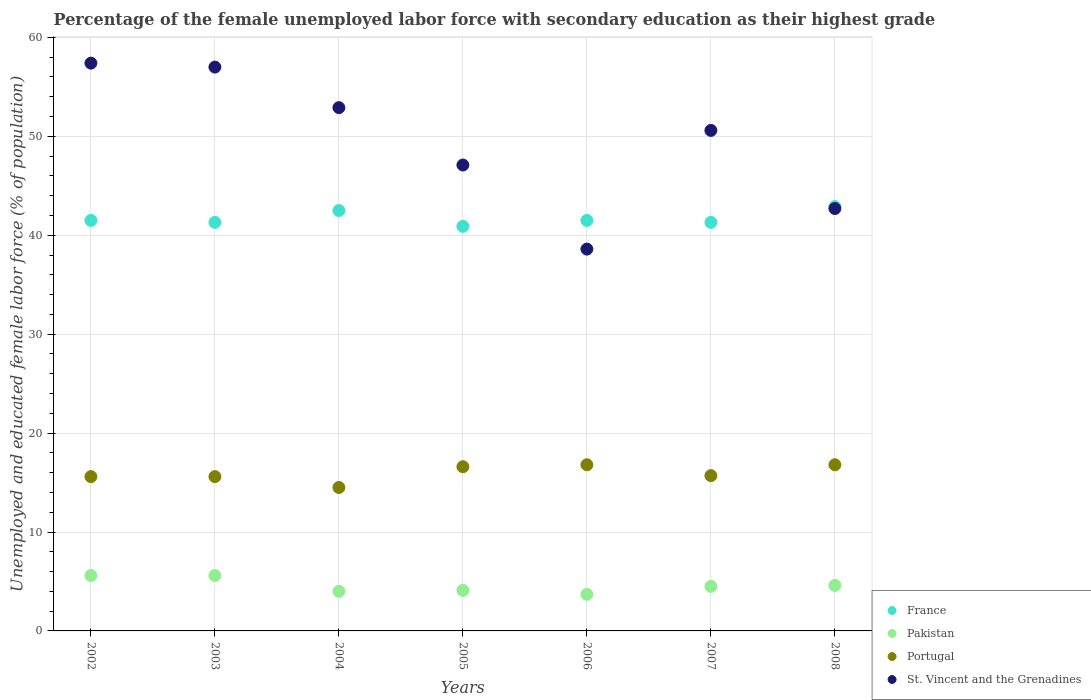How many different coloured dotlines are there?
Make the answer very short. 4. Is the number of dotlines equal to the number of legend labels?
Keep it short and to the point. Yes. What is the percentage of the unemployed female labor force with secondary education in Pakistan in 2002?
Keep it short and to the point. 5.6. Across all years, what is the maximum percentage of the unemployed female labor force with secondary education in Pakistan?
Offer a terse response. 5.6. Across all years, what is the minimum percentage of the unemployed female labor force with secondary education in St. Vincent and the Grenadines?
Your response must be concise. 38.6. What is the total percentage of the unemployed female labor force with secondary education in France in the graph?
Ensure brevity in your answer.  291.9. What is the difference between the percentage of the unemployed female labor force with secondary education in Portugal in 2002 and the percentage of the unemployed female labor force with secondary education in St. Vincent and the Grenadines in 2007?
Your answer should be very brief. -35. What is the average percentage of the unemployed female labor force with secondary education in St. Vincent and the Grenadines per year?
Give a very brief answer. 49.47. In the year 2008, what is the difference between the percentage of the unemployed female labor force with secondary education in Pakistan and percentage of the unemployed female labor force with secondary education in Portugal?
Keep it short and to the point. -12.2. What is the ratio of the percentage of the unemployed female labor force with secondary education in Pakistan in 2003 to that in 2004?
Ensure brevity in your answer.  1.4. What is the difference between the highest and the second highest percentage of the unemployed female labor force with secondary education in France?
Ensure brevity in your answer.  0.4. What is the difference between the highest and the lowest percentage of the unemployed female labor force with secondary education in St. Vincent and the Grenadines?
Keep it short and to the point. 18.8. Is it the case that in every year, the sum of the percentage of the unemployed female labor force with secondary education in Portugal and percentage of the unemployed female labor force with secondary education in Pakistan  is greater than the percentage of the unemployed female labor force with secondary education in St. Vincent and the Grenadines?
Give a very brief answer. No. Is the percentage of the unemployed female labor force with secondary education in Portugal strictly greater than the percentage of the unemployed female labor force with secondary education in Pakistan over the years?
Ensure brevity in your answer.  Yes. How many years are there in the graph?
Keep it short and to the point. 7. What is the difference between two consecutive major ticks on the Y-axis?
Make the answer very short. 10. Are the values on the major ticks of Y-axis written in scientific E-notation?
Your answer should be compact. No. Does the graph contain any zero values?
Make the answer very short. No. How are the legend labels stacked?
Offer a terse response. Vertical. What is the title of the graph?
Your response must be concise. Percentage of the female unemployed labor force with secondary education as their highest grade. Does "Costa Rica" appear as one of the legend labels in the graph?
Provide a succinct answer. No. What is the label or title of the X-axis?
Your response must be concise. Years. What is the label or title of the Y-axis?
Ensure brevity in your answer.  Unemployed and educated female labor force (% of population). What is the Unemployed and educated female labor force (% of population) in France in 2002?
Your response must be concise. 41.5. What is the Unemployed and educated female labor force (% of population) of Pakistan in 2002?
Keep it short and to the point. 5.6. What is the Unemployed and educated female labor force (% of population) of Portugal in 2002?
Keep it short and to the point. 15.6. What is the Unemployed and educated female labor force (% of population) in St. Vincent and the Grenadines in 2002?
Make the answer very short. 57.4. What is the Unemployed and educated female labor force (% of population) of France in 2003?
Give a very brief answer. 41.3. What is the Unemployed and educated female labor force (% of population) in Pakistan in 2003?
Offer a terse response. 5.6. What is the Unemployed and educated female labor force (% of population) in Portugal in 2003?
Ensure brevity in your answer.  15.6. What is the Unemployed and educated female labor force (% of population) of France in 2004?
Give a very brief answer. 42.5. What is the Unemployed and educated female labor force (% of population) of Portugal in 2004?
Provide a succinct answer. 14.5. What is the Unemployed and educated female labor force (% of population) in St. Vincent and the Grenadines in 2004?
Your response must be concise. 52.9. What is the Unemployed and educated female labor force (% of population) of France in 2005?
Your answer should be compact. 40.9. What is the Unemployed and educated female labor force (% of population) in Pakistan in 2005?
Ensure brevity in your answer.  4.1. What is the Unemployed and educated female labor force (% of population) of Portugal in 2005?
Provide a succinct answer. 16.6. What is the Unemployed and educated female labor force (% of population) in St. Vincent and the Grenadines in 2005?
Your response must be concise. 47.1. What is the Unemployed and educated female labor force (% of population) in France in 2006?
Offer a very short reply. 41.5. What is the Unemployed and educated female labor force (% of population) in Pakistan in 2006?
Make the answer very short. 3.7. What is the Unemployed and educated female labor force (% of population) of Portugal in 2006?
Your answer should be very brief. 16.8. What is the Unemployed and educated female labor force (% of population) in St. Vincent and the Grenadines in 2006?
Offer a very short reply. 38.6. What is the Unemployed and educated female labor force (% of population) of France in 2007?
Your answer should be compact. 41.3. What is the Unemployed and educated female labor force (% of population) of Portugal in 2007?
Provide a short and direct response. 15.7. What is the Unemployed and educated female labor force (% of population) of St. Vincent and the Grenadines in 2007?
Provide a short and direct response. 50.6. What is the Unemployed and educated female labor force (% of population) of France in 2008?
Your answer should be very brief. 42.9. What is the Unemployed and educated female labor force (% of population) of Pakistan in 2008?
Ensure brevity in your answer.  4.6. What is the Unemployed and educated female labor force (% of population) in Portugal in 2008?
Offer a very short reply. 16.8. What is the Unemployed and educated female labor force (% of population) of St. Vincent and the Grenadines in 2008?
Ensure brevity in your answer.  42.7. Across all years, what is the maximum Unemployed and educated female labor force (% of population) in France?
Ensure brevity in your answer.  42.9. Across all years, what is the maximum Unemployed and educated female labor force (% of population) in Pakistan?
Ensure brevity in your answer.  5.6. Across all years, what is the maximum Unemployed and educated female labor force (% of population) of Portugal?
Your answer should be compact. 16.8. Across all years, what is the maximum Unemployed and educated female labor force (% of population) in St. Vincent and the Grenadines?
Ensure brevity in your answer.  57.4. Across all years, what is the minimum Unemployed and educated female labor force (% of population) in France?
Keep it short and to the point. 40.9. Across all years, what is the minimum Unemployed and educated female labor force (% of population) of Pakistan?
Keep it short and to the point. 3.7. Across all years, what is the minimum Unemployed and educated female labor force (% of population) in St. Vincent and the Grenadines?
Your answer should be very brief. 38.6. What is the total Unemployed and educated female labor force (% of population) of France in the graph?
Provide a short and direct response. 291.9. What is the total Unemployed and educated female labor force (% of population) in Pakistan in the graph?
Your response must be concise. 32.1. What is the total Unemployed and educated female labor force (% of population) in Portugal in the graph?
Provide a short and direct response. 111.6. What is the total Unemployed and educated female labor force (% of population) of St. Vincent and the Grenadines in the graph?
Your answer should be very brief. 346.3. What is the difference between the Unemployed and educated female labor force (% of population) of France in 2002 and that in 2003?
Provide a short and direct response. 0.2. What is the difference between the Unemployed and educated female labor force (% of population) of Pakistan in 2002 and that in 2004?
Offer a very short reply. 1.6. What is the difference between the Unemployed and educated female labor force (% of population) in Portugal in 2002 and that in 2004?
Provide a succinct answer. 1.1. What is the difference between the Unemployed and educated female labor force (% of population) of St. Vincent and the Grenadines in 2002 and that in 2004?
Provide a succinct answer. 4.5. What is the difference between the Unemployed and educated female labor force (% of population) in France in 2002 and that in 2005?
Ensure brevity in your answer.  0.6. What is the difference between the Unemployed and educated female labor force (% of population) of Pakistan in 2002 and that in 2005?
Provide a succinct answer. 1.5. What is the difference between the Unemployed and educated female labor force (% of population) of Portugal in 2002 and that in 2005?
Your answer should be compact. -1. What is the difference between the Unemployed and educated female labor force (% of population) of Pakistan in 2002 and that in 2006?
Your answer should be compact. 1.9. What is the difference between the Unemployed and educated female labor force (% of population) in Portugal in 2002 and that in 2006?
Ensure brevity in your answer.  -1.2. What is the difference between the Unemployed and educated female labor force (% of population) of St. Vincent and the Grenadines in 2002 and that in 2006?
Ensure brevity in your answer.  18.8. What is the difference between the Unemployed and educated female labor force (% of population) in Portugal in 2002 and that in 2007?
Ensure brevity in your answer.  -0.1. What is the difference between the Unemployed and educated female labor force (% of population) of St. Vincent and the Grenadines in 2002 and that in 2007?
Offer a very short reply. 6.8. What is the difference between the Unemployed and educated female labor force (% of population) of France in 2002 and that in 2008?
Your answer should be very brief. -1.4. What is the difference between the Unemployed and educated female labor force (% of population) in Pakistan in 2002 and that in 2008?
Make the answer very short. 1. What is the difference between the Unemployed and educated female labor force (% of population) of France in 2003 and that in 2004?
Your answer should be very brief. -1.2. What is the difference between the Unemployed and educated female labor force (% of population) in St. Vincent and the Grenadines in 2003 and that in 2004?
Your response must be concise. 4.1. What is the difference between the Unemployed and educated female labor force (% of population) of Portugal in 2003 and that in 2005?
Keep it short and to the point. -1. What is the difference between the Unemployed and educated female labor force (% of population) of France in 2003 and that in 2006?
Make the answer very short. -0.2. What is the difference between the Unemployed and educated female labor force (% of population) of Portugal in 2003 and that in 2006?
Offer a terse response. -1.2. What is the difference between the Unemployed and educated female labor force (% of population) of St. Vincent and the Grenadines in 2003 and that in 2006?
Your answer should be compact. 18.4. What is the difference between the Unemployed and educated female labor force (% of population) in Pakistan in 2003 and that in 2007?
Provide a short and direct response. 1.1. What is the difference between the Unemployed and educated female labor force (% of population) of Pakistan in 2003 and that in 2008?
Your answer should be very brief. 1. What is the difference between the Unemployed and educated female labor force (% of population) of France in 2004 and that in 2006?
Offer a terse response. 1. What is the difference between the Unemployed and educated female labor force (% of population) of Portugal in 2004 and that in 2006?
Keep it short and to the point. -2.3. What is the difference between the Unemployed and educated female labor force (% of population) of St. Vincent and the Grenadines in 2004 and that in 2006?
Ensure brevity in your answer.  14.3. What is the difference between the Unemployed and educated female labor force (% of population) in Pakistan in 2004 and that in 2007?
Offer a very short reply. -0.5. What is the difference between the Unemployed and educated female labor force (% of population) of St. Vincent and the Grenadines in 2004 and that in 2007?
Give a very brief answer. 2.3. What is the difference between the Unemployed and educated female labor force (% of population) of Pakistan in 2004 and that in 2008?
Offer a terse response. -0.6. What is the difference between the Unemployed and educated female labor force (% of population) of Portugal in 2004 and that in 2008?
Ensure brevity in your answer.  -2.3. What is the difference between the Unemployed and educated female labor force (% of population) of St. Vincent and the Grenadines in 2004 and that in 2008?
Ensure brevity in your answer.  10.2. What is the difference between the Unemployed and educated female labor force (% of population) in Portugal in 2005 and that in 2006?
Make the answer very short. -0.2. What is the difference between the Unemployed and educated female labor force (% of population) of Pakistan in 2005 and that in 2007?
Offer a very short reply. -0.4. What is the difference between the Unemployed and educated female labor force (% of population) of France in 2005 and that in 2008?
Keep it short and to the point. -2. What is the difference between the Unemployed and educated female labor force (% of population) in Portugal in 2005 and that in 2008?
Make the answer very short. -0.2. What is the difference between the Unemployed and educated female labor force (% of population) of St. Vincent and the Grenadines in 2005 and that in 2008?
Give a very brief answer. 4.4. What is the difference between the Unemployed and educated female labor force (% of population) in Pakistan in 2006 and that in 2008?
Your answer should be very brief. -0.9. What is the difference between the Unemployed and educated female labor force (% of population) in Portugal in 2006 and that in 2008?
Your answer should be compact. 0. What is the difference between the Unemployed and educated female labor force (% of population) in St. Vincent and the Grenadines in 2006 and that in 2008?
Provide a succinct answer. -4.1. What is the difference between the Unemployed and educated female labor force (% of population) in France in 2007 and that in 2008?
Give a very brief answer. -1.6. What is the difference between the Unemployed and educated female labor force (% of population) in Portugal in 2007 and that in 2008?
Offer a terse response. -1.1. What is the difference between the Unemployed and educated female labor force (% of population) of St. Vincent and the Grenadines in 2007 and that in 2008?
Provide a short and direct response. 7.9. What is the difference between the Unemployed and educated female labor force (% of population) of France in 2002 and the Unemployed and educated female labor force (% of population) of Pakistan in 2003?
Your answer should be very brief. 35.9. What is the difference between the Unemployed and educated female labor force (% of population) in France in 2002 and the Unemployed and educated female labor force (% of population) in Portugal in 2003?
Your answer should be compact. 25.9. What is the difference between the Unemployed and educated female labor force (% of population) in France in 2002 and the Unemployed and educated female labor force (% of population) in St. Vincent and the Grenadines in 2003?
Make the answer very short. -15.5. What is the difference between the Unemployed and educated female labor force (% of population) of Pakistan in 2002 and the Unemployed and educated female labor force (% of population) of St. Vincent and the Grenadines in 2003?
Offer a terse response. -51.4. What is the difference between the Unemployed and educated female labor force (% of population) of Portugal in 2002 and the Unemployed and educated female labor force (% of population) of St. Vincent and the Grenadines in 2003?
Your answer should be very brief. -41.4. What is the difference between the Unemployed and educated female labor force (% of population) in France in 2002 and the Unemployed and educated female labor force (% of population) in Pakistan in 2004?
Your answer should be very brief. 37.5. What is the difference between the Unemployed and educated female labor force (% of population) of France in 2002 and the Unemployed and educated female labor force (% of population) of Portugal in 2004?
Your answer should be very brief. 27. What is the difference between the Unemployed and educated female labor force (% of population) in France in 2002 and the Unemployed and educated female labor force (% of population) in St. Vincent and the Grenadines in 2004?
Offer a terse response. -11.4. What is the difference between the Unemployed and educated female labor force (% of population) of Pakistan in 2002 and the Unemployed and educated female labor force (% of population) of Portugal in 2004?
Keep it short and to the point. -8.9. What is the difference between the Unemployed and educated female labor force (% of population) of Pakistan in 2002 and the Unemployed and educated female labor force (% of population) of St. Vincent and the Grenadines in 2004?
Keep it short and to the point. -47.3. What is the difference between the Unemployed and educated female labor force (% of population) of Portugal in 2002 and the Unemployed and educated female labor force (% of population) of St. Vincent and the Grenadines in 2004?
Provide a short and direct response. -37.3. What is the difference between the Unemployed and educated female labor force (% of population) of France in 2002 and the Unemployed and educated female labor force (% of population) of Pakistan in 2005?
Keep it short and to the point. 37.4. What is the difference between the Unemployed and educated female labor force (% of population) in France in 2002 and the Unemployed and educated female labor force (% of population) in Portugal in 2005?
Offer a terse response. 24.9. What is the difference between the Unemployed and educated female labor force (% of population) of Pakistan in 2002 and the Unemployed and educated female labor force (% of population) of St. Vincent and the Grenadines in 2005?
Offer a terse response. -41.5. What is the difference between the Unemployed and educated female labor force (% of population) of Portugal in 2002 and the Unemployed and educated female labor force (% of population) of St. Vincent and the Grenadines in 2005?
Offer a very short reply. -31.5. What is the difference between the Unemployed and educated female labor force (% of population) of France in 2002 and the Unemployed and educated female labor force (% of population) of Pakistan in 2006?
Offer a terse response. 37.8. What is the difference between the Unemployed and educated female labor force (% of population) in France in 2002 and the Unemployed and educated female labor force (% of population) in Portugal in 2006?
Ensure brevity in your answer.  24.7. What is the difference between the Unemployed and educated female labor force (% of population) of France in 2002 and the Unemployed and educated female labor force (% of population) of St. Vincent and the Grenadines in 2006?
Provide a short and direct response. 2.9. What is the difference between the Unemployed and educated female labor force (% of population) of Pakistan in 2002 and the Unemployed and educated female labor force (% of population) of Portugal in 2006?
Provide a succinct answer. -11.2. What is the difference between the Unemployed and educated female labor force (% of population) of Pakistan in 2002 and the Unemployed and educated female labor force (% of population) of St. Vincent and the Grenadines in 2006?
Offer a very short reply. -33. What is the difference between the Unemployed and educated female labor force (% of population) in Portugal in 2002 and the Unemployed and educated female labor force (% of population) in St. Vincent and the Grenadines in 2006?
Your answer should be very brief. -23. What is the difference between the Unemployed and educated female labor force (% of population) in France in 2002 and the Unemployed and educated female labor force (% of population) in Pakistan in 2007?
Provide a succinct answer. 37. What is the difference between the Unemployed and educated female labor force (% of population) of France in 2002 and the Unemployed and educated female labor force (% of population) of Portugal in 2007?
Offer a very short reply. 25.8. What is the difference between the Unemployed and educated female labor force (% of population) of France in 2002 and the Unemployed and educated female labor force (% of population) of St. Vincent and the Grenadines in 2007?
Provide a succinct answer. -9.1. What is the difference between the Unemployed and educated female labor force (% of population) of Pakistan in 2002 and the Unemployed and educated female labor force (% of population) of St. Vincent and the Grenadines in 2007?
Provide a succinct answer. -45. What is the difference between the Unemployed and educated female labor force (% of population) in Portugal in 2002 and the Unemployed and educated female labor force (% of population) in St. Vincent and the Grenadines in 2007?
Give a very brief answer. -35. What is the difference between the Unemployed and educated female labor force (% of population) of France in 2002 and the Unemployed and educated female labor force (% of population) of Pakistan in 2008?
Ensure brevity in your answer.  36.9. What is the difference between the Unemployed and educated female labor force (% of population) in France in 2002 and the Unemployed and educated female labor force (% of population) in Portugal in 2008?
Ensure brevity in your answer.  24.7. What is the difference between the Unemployed and educated female labor force (% of population) of France in 2002 and the Unemployed and educated female labor force (% of population) of St. Vincent and the Grenadines in 2008?
Give a very brief answer. -1.2. What is the difference between the Unemployed and educated female labor force (% of population) in Pakistan in 2002 and the Unemployed and educated female labor force (% of population) in Portugal in 2008?
Your response must be concise. -11.2. What is the difference between the Unemployed and educated female labor force (% of population) of Pakistan in 2002 and the Unemployed and educated female labor force (% of population) of St. Vincent and the Grenadines in 2008?
Provide a short and direct response. -37.1. What is the difference between the Unemployed and educated female labor force (% of population) in Portugal in 2002 and the Unemployed and educated female labor force (% of population) in St. Vincent and the Grenadines in 2008?
Keep it short and to the point. -27.1. What is the difference between the Unemployed and educated female labor force (% of population) of France in 2003 and the Unemployed and educated female labor force (% of population) of Pakistan in 2004?
Your answer should be very brief. 37.3. What is the difference between the Unemployed and educated female labor force (% of population) of France in 2003 and the Unemployed and educated female labor force (% of population) of Portugal in 2004?
Your answer should be compact. 26.8. What is the difference between the Unemployed and educated female labor force (% of population) of France in 2003 and the Unemployed and educated female labor force (% of population) of St. Vincent and the Grenadines in 2004?
Give a very brief answer. -11.6. What is the difference between the Unemployed and educated female labor force (% of population) in Pakistan in 2003 and the Unemployed and educated female labor force (% of population) in St. Vincent and the Grenadines in 2004?
Make the answer very short. -47.3. What is the difference between the Unemployed and educated female labor force (% of population) in Portugal in 2003 and the Unemployed and educated female labor force (% of population) in St. Vincent and the Grenadines in 2004?
Provide a succinct answer. -37.3. What is the difference between the Unemployed and educated female labor force (% of population) of France in 2003 and the Unemployed and educated female labor force (% of population) of Pakistan in 2005?
Provide a succinct answer. 37.2. What is the difference between the Unemployed and educated female labor force (% of population) of France in 2003 and the Unemployed and educated female labor force (% of population) of Portugal in 2005?
Provide a short and direct response. 24.7. What is the difference between the Unemployed and educated female labor force (% of population) in Pakistan in 2003 and the Unemployed and educated female labor force (% of population) in St. Vincent and the Grenadines in 2005?
Your response must be concise. -41.5. What is the difference between the Unemployed and educated female labor force (% of population) of Portugal in 2003 and the Unemployed and educated female labor force (% of population) of St. Vincent and the Grenadines in 2005?
Ensure brevity in your answer.  -31.5. What is the difference between the Unemployed and educated female labor force (% of population) of France in 2003 and the Unemployed and educated female labor force (% of population) of Pakistan in 2006?
Ensure brevity in your answer.  37.6. What is the difference between the Unemployed and educated female labor force (% of population) in France in 2003 and the Unemployed and educated female labor force (% of population) in Portugal in 2006?
Offer a terse response. 24.5. What is the difference between the Unemployed and educated female labor force (% of population) of Pakistan in 2003 and the Unemployed and educated female labor force (% of population) of Portugal in 2006?
Provide a short and direct response. -11.2. What is the difference between the Unemployed and educated female labor force (% of population) in Pakistan in 2003 and the Unemployed and educated female labor force (% of population) in St. Vincent and the Grenadines in 2006?
Give a very brief answer. -33. What is the difference between the Unemployed and educated female labor force (% of population) of Portugal in 2003 and the Unemployed and educated female labor force (% of population) of St. Vincent and the Grenadines in 2006?
Offer a very short reply. -23. What is the difference between the Unemployed and educated female labor force (% of population) in France in 2003 and the Unemployed and educated female labor force (% of population) in Pakistan in 2007?
Your answer should be very brief. 36.8. What is the difference between the Unemployed and educated female labor force (% of population) of France in 2003 and the Unemployed and educated female labor force (% of population) of Portugal in 2007?
Provide a short and direct response. 25.6. What is the difference between the Unemployed and educated female labor force (% of population) in Pakistan in 2003 and the Unemployed and educated female labor force (% of population) in Portugal in 2007?
Your answer should be compact. -10.1. What is the difference between the Unemployed and educated female labor force (% of population) of Pakistan in 2003 and the Unemployed and educated female labor force (% of population) of St. Vincent and the Grenadines in 2007?
Give a very brief answer. -45. What is the difference between the Unemployed and educated female labor force (% of population) in Portugal in 2003 and the Unemployed and educated female labor force (% of population) in St. Vincent and the Grenadines in 2007?
Your response must be concise. -35. What is the difference between the Unemployed and educated female labor force (% of population) in France in 2003 and the Unemployed and educated female labor force (% of population) in Pakistan in 2008?
Offer a very short reply. 36.7. What is the difference between the Unemployed and educated female labor force (% of population) of France in 2003 and the Unemployed and educated female labor force (% of population) of St. Vincent and the Grenadines in 2008?
Your answer should be very brief. -1.4. What is the difference between the Unemployed and educated female labor force (% of population) of Pakistan in 2003 and the Unemployed and educated female labor force (% of population) of Portugal in 2008?
Provide a succinct answer. -11.2. What is the difference between the Unemployed and educated female labor force (% of population) of Pakistan in 2003 and the Unemployed and educated female labor force (% of population) of St. Vincent and the Grenadines in 2008?
Your answer should be compact. -37.1. What is the difference between the Unemployed and educated female labor force (% of population) in Portugal in 2003 and the Unemployed and educated female labor force (% of population) in St. Vincent and the Grenadines in 2008?
Keep it short and to the point. -27.1. What is the difference between the Unemployed and educated female labor force (% of population) in France in 2004 and the Unemployed and educated female labor force (% of population) in Pakistan in 2005?
Provide a short and direct response. 38.4. What is the difference between the Unemployed and educated female labor force (% of population) of France in 2004 and the Unemployed and educated female labor force (% of population) of Portugal in 2005?
Your response must be concise. 25.9. What is the difference between the Unemployed and educated female labor force (% of population) of France in 2004 and the Unemployed and educated female labor force (% of population) of St. Vincent and the Grenadines in 2005?
Ensure brevity in your answer.  -4.6. What is the difference between the Unemployed and educated female labor force (% of population) of Pakistan in 2004 and the Unemployed and educated female labor force (% of population) of St. Vincent and the Grenadines in 2005?
Your answer should be compact. -43.1. What is the difference between the Unemployed and educated female labor force (% of population) of Portugal in 2004 and the Unemployed and educated female labor force (% of population) of St. Vincent and the Grenadines in 2005?
Your answer should be compact. -32.6. What is the difference between the Unemployed and educated female labor force (% of population) in France in 2004 and the Unemployed and educated female labor force (% of population) in Pakistan in 2006?
Offer a very short reply. 38.8. What is the difference between the Unemployed and educated female labor force (% of population) of France in 2004 and the Unemployed and educated female labor force (% of population) of Portugal in 2006?
Offer a very short reply. 25.7. What is the difference between the Unemployed and educated female labor force (% of population) in Pakistan in 2004 and the Unemployed and educated female labor force (% of population) in Portugal in 2006?
Your answer should be compact. -12.8. What is the difference between the Unemployed and educated female labor force (% of population) of Pakistan in 2004 and the Unemployed and educated female labor force (% of population) of St. Vincent and the Grenadines in 2006?
Make the answer very short. -34.6. What is the difference between the Unemployed and educated female labor force (% of population) of Portugal in 2004 and the Unemployed and educated female labor force (% of population) of St. Vincent and the Grenadines in 2006?
Your answer should be compact. -24.1. What is the difference between the Unemployed and educated female labor force (% of population) in France in 2004 and the Unemployed and educated female labor force (% of population) in Pakistan in 2007?
Give a very brief answer. 38. What is the difference between the Unemployed and educated female labor force (% of population) of France in 2004 and the Unemployed and educated female labor force (% of population) of Portugal in 2007?
Ensure brevity in your answer.  26.8. What is the difference between the Unemployed and educated female labor force (% of population) of Pakistan in 2004 and the Unemployed and educated female labor force (% of population) of Portugal in 2007?
Your response must be concise. -11.7. What is the difference between the Unemployed and educated female labor force (% of population) of Pakistan in 2004 and the Unemployed and educated female labor force (% of population) of St. Vincent and the Grenadines in 2007?
Ensure brevity in your answer.  -46.6. What is the difference between the Unemployed and educated female labor force (% of population) in Portugal in 2004 and the Unemployed and educated female labor force (% of population) in St. Vincent and the Grenadines in 2007?
Your answer should be compact. -36.1. What is the difference between the Unemployed and educated female labor force (% of population) of France in 2004 and the Unemployed and educated female labor force (% of population) of Pakistan in 2008?
Your answer should be compact. 37.9. What is the difference between the Unemployed and educated female labor force (% of population) in France in 2004 and the Unemployed and educated female labor force (% of population) in Portugal in 2008?
Your answer should be very brief. 25.7. What is the difference between the Unemployed and educated female labor force (% of population) in France in 2004 and the Unemployed and educated female labor force (% of population) in St. Vincent and the Grenadines in 2008?
Provide a succinct answer. -0.2. What is the difference between the Unemployed and educated female labor force (% of population) in Pakistan in 2004 and the Unemployed and educated female labor force (% of population) in St. Vincent and the Grenadines in 2008?
Give a very brief answer. -38.7. What is the difference between the Unemployed and educated female labor force (% of population) of Portugal in 2004 and the Unemployed and educated female labor force (% of population) of St. Vincent and the Grenadines in 2008?
Ensure brevity in your answer.  -28.2. What is the difference between the Unemployed and educated female labor force (% of population) in France in 2005 and the Unemployed and educated female labor force (% of population) in Pakistan in 2006?
Offer a very short reply. 37.2. What is the difference between the Unemployed and educated female labor force (% of population) in France in 2005 and the Unemployed and educated female labor force (% of population) in Portugal in 2006?
Offer a terse response. 24.1. What is the difference between the Unemployed and educated female labor force (% of population) in France in 2005 and the Unemployed and educated female labor force (% of population) in St. Vincent and the Grenadines in 2006?
Give a very brief answer. 2.3. What is the difference between the Unemployed and educated female labor force (% of population) of Pakistan in 2005 and the Unemployed and educated female labor force (% of population) of St. Vincent and the Grenadines in 2006?
Keep it short and to the point. -34.5. What is the difference between the Unemployed and educated female labor force (% of population) of France in 2005 and the Unemployed and educated female labor force (% of population) of Pakistan in 2007?
Give a very brief answer. 36.4. What is the difference between the Unemployed and educated female labor force (% of population) in France in 2005 and the Unemployed and educated female labor force (% of population) in Portugal in 2007?
Offer a terse response. 25.2. What is the difference between the Unemployed and educated female labor force (% of population) in Pakistan in 2005 and the Unemployed and educated female labor force (% of population) in St. Vincent and the Grenadines in 2007?
Your answer should be very brief. -46.5. What is the difference between the Unemployed and educated female labor force (% of population) of Portugal in 2005 and the Unemployed and educated female labor force (% of population) of St. Vincent and the Grenadines in 2007?
Provide a succinct answer. -34. What is the difference between the Unemployed and educated female labor force (% of population) in France in 2005 and the Unemployed and educated female labor force (% of population) in Pakistan in 2008?
Provide a succinct answer. 36.3. What is the difference between the Unemployed and educated female labor force (% of population) of France in 2005 and the Unemployed and educated female labor force (% of population) of Portugal in 2008?
Keep it short and to the point. 24.1. What is the difference between the Unemployed and educated female labor force (% of population) in Pakistan in 2005 and the Unemployed and educated female labor force (% of population) in Portugal in 2008?
Offer a terse response. -12.7. What is the difference between the Unemployed and educated female labor force (% of population) of Pakistan in 2005 and the Unemployed and educated female labor force (% of population) of St. Vincent and the Grenadines in 2008?
Give a very brief answer. -38.6. What is the difference between the Unemployed and educated female labor force (% of population) of Portugal in 2005 and the Unemployed and educated female labor force (% of population) of St. Vincent and the Grenadines in 2008?
Make the answer very short. -26.1. What is the difference between the Unemployed and educated female labor force (% of population) of France in 2006 and the Unemployed and educated female labor force (% of population) of Portugal in 2007?
Your answer should be compact. 25.8. What is the difference between the Unemployed and educated female labor force (% of population) in France in 2006 and the Unemployed and educated female labor force (% of population) in St. Vincent and the Grenadines in 2007?
Give a very brief answer. -9.1. What is the difference between the Unemployed and educated female labor force (% of population) in Pakistan in 2006 and the Unemployed and educated female labor force (% of population) in St. Vincent and the Grenadines in 2007?
Ensure brevity in your answer.  -46.9. What is the difference between the Unemployed and educated female labor force (% of population) of Portugal in 2006 and the Unemployed and educated female labor force (% of population) of St. Vincent and the Grenadines in 2007?
Provide a short and direct response. -33.8. What is the difference between the Unemployed and educated female labor force (% of population) in France in 2006 and the Unemployed and educated female labor force (% of population) in Pakistan in 2008?
Offer a terse response. 36.9. What is the difference between the Unemployed and educated female labor force (% of population) in France in 2006 and the Unemployed and educated female labor force (% of population) in Portugal in 2008?
Your response must be concise. 24.7. What is the difference between the Unemployed and educated female labor force (% of population) in Pakistan in 2006 and the Unemployed and educated female labor force (% of population) in Portugal in 2008?
Give a very brief answer. -13.1. What is the difference between the Unemployed and educated female labor force (% of population) of Pakistan in 2006 and the Unemployed and educated female labor force (% of population) of St. Vincent and the Grenadines in 2008?
Give a very brief answer. -39. What is the difference between the Unemployed and educated female labor force (% of population) in Portugal in 2006 and the Unemployed and educated female labor force (% of population) in St. Vincent and the Grenadines in 2008?
Make the answer very short. -25.9. What is the difference between the Unemployed and educated female labor force (% of population) in France in 2007 and the Unemployed and educated female labor force (% of population) in Pakistan in 2008?
Provide a succinct answer. 36.7. What is the difference between the Unemployed and educated female labor force (% of population) in France in 2007 and the Unemployed and educated female labor force (% of population) in Portugal in 2008?
Your answer should be very brief. 24.5. What is the difference between the Unemployed and educated female labor force (% of population) of France in 2007 and the Unemployed and educated female labor force (% of population) of St. Vincent and the Grenadines in 2008?
Ensure brevity in your answer.  -1.4. What is the difference between the Unemployed and educated female labor force (% of population) of Pakistan in 2007 and the Unemployed and educated female labor force (% of population) of Portugal in 2008?
Give a very brief answer. -12.3. What is the difference between the Unemployed and educated female labor force (% of population) in Pakistan in 2007 and the Unemployed and educated female labor force (% of population) in St. Vincent and the Grenadines in 2008?
Your response must be concise. -38.2. What is the average Unemployed and educated female labor force (% of population) of France per year?
Give a very brief answer. 41.7. What is the average Unemployed and educated female labor force (% of population) of Pakistan per year?
Offer a terse response. 4.59. What is the average Unemployed and educated female labor force (% of population) in Portugal per year?
Offer a very short reply. 15.94. What is the average Unemployed and educated female labor force (% of population) in St. Vincent and the Grenadines per year?
Provide a short and direct response. 49.47. In the year 2002, what is the difference between the Unemployed and educated female labor force (% of population) in France and Unemployed and educated female labor force (% of population) in Pakistan?
Your response must be concise. 35.9. In the year 2002, what is the difference between the Unemployed and educated female labor force (% of population) of France and Unemployed and educated female labor force (% of population) of Portugal?
Provide a short and direct response. 25.9. In the year 2002, what is the difference between the Unemployed and educated female labor force (% of population) in France and Unemployed and educated female labor force (% of population) in St. Vincent and the Grenadines?
Your response must be concise. -15.9. In the year 2002, what is the difference between the Unemployed and educated female labor force (% of population) in Pakistan and Unemployed and educated female labor force (% of population) in Portugal?
Your response must be concise. -10. In the year 2002, what is the difference between the Unemployed and educated female labor force (% of population) in Pakistan and Unemployed and educated female labor force (% of population) in St. Vincent and the Grenadines?
Keep it short and to the point. -51.8. In the year 2002, what is the difference between the Unemployed and educated female labor force (% of population) of Portugal and Unemployed and educated female labor force (% of population) of St. Vincent and the Grenadines?
Provide a short and direct response. -41.8. In the year 2003, what is the difference between the Unemployed and educated female labor force (% of population) in France and Unemployed and educated female labor force (% of population) in Pakistan?
Ensure brevity in your answer.  35.7. In the year 2003, what is the difference between the Unemployed and educated female labor force (% of population) in France and Unemployed and educated female labor force (% of population) in Portugal?
Ensure brevity in your answer.  25.7. In the year 2003, what is the difference between the Unemployed and educated female labor force (% of population) in France and Unemployed and educated female labor force (% of population) in St. Vincent and the Grenadines?
Your answer should be very brief. -15.7. In the year 2003, what is the difference between the Unemployed and educated female labor force (% of population) in Pakistan and Unemployed and educated female labor force (% of population) in Portugal?
Your answer should be very brief. -10. In the year 2003, what is the difference between the Unemployed and educated female labor force (% of population) in Pakistan and Unemployed and educated female labor force (% of population) in St. Vincent and the Grenadines?
Ensure brevity in your answer.  -51.4. In the year 2003, what is the difference between the Unemployed and educated female labor force (% of population) of Portugal and Unemployed and educated female labor force (% of population) of St. Vincent and the Grenadines?
Ensure brevity in your answer.  -41.4. In the year 2004, what is the difference between the Unemployed and educated female labor force (% of population) of France and Unemployed and educated female labor force (% of population) of Pakistan?
Give a very brief answer. 38.5. In the year 2004, what is the difference between the Unemployed and educated female labor force (% of population) in France and Unemployed and educated female labor force (% of population) in Portugal?
Make the answer very short. 28. In the year 2004, what is the difference between the Unemployed and educated female labor force (% of population) in Pakistan and Unemployed and educated female labor force (% of population) in St. Vincent and the Grenadines?
Make the answer very short. -48.9. In the year 2004, what is the difference between the Unemployed and educated female labor force (% of population) of Portugal and Unemployed and educated female labor force (% of population) of St. Vincent and the Grenadines?
Offer a very short reply. -38.4. In the year 2005, what is the difference between the Unemployed and educated female labor force (% of population) in France and Unemployed and educated female labor force (% of population) in Pakistan?
Give a very brief answer. 36.8. In the year 2005, what is the difference between the Unemployed and educated female labor force (% of population) of France and Unemployed and educated female labor force (% of population) of Portugal?
Offer a terse response. 24.3. In the year 2005, what is the difference between the Unemployed and educated female labor force (% of population) of Pakistan and Unemployed and educated female labor force (% of population) of St. Vincent and the Grenadines?
Your response must be concise. -43. In the year 2005, what is the difference between the Unemployed and educated female labor force (% of population) of Portugal and Unemployed and educated female labor force (% of population) of St. Vincent and the Grenadines?
Keep it short and to the point. -30.5. In the year 2006, what is the difference between the Unemployed and educated female labor force (% of population) of France and Unemployed and educated female labor force (% of population) of Pakistan?
Your answer should be compact. 37.8. In the year 2006, what is the difference between the Unemployed and educated female labor force (% of population) of France and Unemployed and educated female labor force (% of population) of Portugal?
Offer a terse response. 24.7. In the year 2006, what is the difference between the Unemployed and educated female labor force (% of population) in Pakistan and Unemployed and educated female labor force (% of population) in Portugal?
Your answer should be compact. -13.1. In the year 2006, what is the difference between the Unemployed and educated female labor force (% of population) of Pakistan and Unemployed and educated female labor force (% of population) of St. Vincent and the Grenadines?
Ensure brevity in your answer.  -34.9. In the year 2006, what is the difference between the Unemployed and educated female labor force (% of population) of Portugal and Unemployed and educated female labor force (% of population) of St. Vincent and the Grenadines?
Keep it short and to the point. -21.8. In the year 2007, what is the difference between the Unemployed and educated female labor force (% of population) of France and Unemployed and educated female labor force (% of population) of Pakistan?
Your answer should be compact. 36.8. In the year 2007, what is the difference between the Unemployed and educated female labor force (% of population) in France and Unemployed and educated female labor force (% of population) in Portugal?
Your response must be concise. 25.6. In the year 2007, what is the difference between the Unemployed and educated female labor force (% of population) in France and Unemployed and educated female labor force (% of population) in St. Vincent and the Grenadines?
Offer a terse response. -9.3. In the year 2007, what is the difference between the Unemployed and educated female labor force (% of population) of Pakistan and Unemployed and educated female labor force (% of population) of St. Vincent and the Grenadines?
Give a very brief answer. -46.1. In the year 2007, what is the difference between the Unemployed and educated female labor force (% of population) of Portugal and Unemployed and educated female labor force (% of population) of St. Vincent and the Grenadines?
Your answer should be very brief. -34.9. In the year 2008, what is the difference between the Unemployed and educated female labor force (% of population) in France and Unemployed and educated female labor force (% of population) in Pakistan?
Provide a succinct answer. 38.3. In the year 2008, what is the difference between the Unemployed and educated female labor force (% of population) in France and Unemployed and educated female labor force (% of population) in Portugal?
Offer a terse response. 26.1. In the year 2008, what is the difference between the Unemployed and educated female labor force (% of population) in Pakistan and Unemployed and educated female labor force (% of population) in St. Vincent and the Grenadines?
Your response must be concise. -38.1. In the year 2008, what is the difference between the Unemployed and educated female labor force (% of population) of Portugal and Unemployed and educated female labor force (% of population) of St. Vincent and the Grenadines?
Offer a terse response. -25.9. What is the ratio of the Unemployed and educated female labor force (% of population) in St. Vincent and the Grenadines in 2002 to that in 2003?
Your response must be concise. 1.01. What is the ratio of the Unemployed and educated female labor force (% of population) of France in 2002 to that in 2004?
Provide a short and direct response. 0.98. What is the ratio of the Unemployed and educated female labor force (% of population) of Portugal in 2002 to that in 2004?
Your answer should be very brief. 1.08. What is the ratio of the Unemployed and educated female labor force (% of population) in St. Vincent and the Grenadines in 2002 to that in 2004?
Offer a terse response. 1.09. What is the ratio of the Unemployed and educated female labor force (% of population) in France in 2002 to that in 2005?
Keep it short and to the point. 1.01. What is the ratio of the Unemployed and educated female labor force (% of population) of Pakistan in 2002 to that in 2005?
Ensure brevity in your answer.  1.37. What is the ratio of the Unemployed and educated female labor force (% of population) of Portugal in 2002 to that in 2005?
Provide a succinct answer. 0.94. What is the ratio of the Unemployed and educated female labor force (% of population) of St. Vincent and the Grenadines in 2002 to that in 2005?
Provide a succinct answer. 1.22. What is the ratio of the Unemployed and educated female labor force (% of population) of Pakistan in 2002 to that in 2006?
Make the answer very short. 1.51. What is the ratio of the Unemployed and educated female labor force (% of population) of Portugal in 2002 to that in 2006?
Your response must be concise. 0.93. What is the ratio of the Unemployed and educated female labor force (% of population) in St. Vincent and the Grenadines in 2002 to that in 2006?
Your answer should be compact. 1.49. What is the ratio of the Unemployed and educated female labor force (% of population) of France in 2002 to that in 2007?
Your answer should be compact. 1. What is the ratio of the Unemployed and educated female labor force (% of population) of Pakistan in 2002 to that in 2007?
Make the answer very short. 1.24. What is the ratio of the Unemployed and educated female labor force (% of population) in St. Vincent and the Grenadines in 2002 to that in 2007?
Offer a terse response. 1.13. What is the ratio of the Unemployed and educated female labor force (% of population) of France in 2002 to that in 2008?
Provide a succinct answer. 0.97. What is the ratio of the Unemployed and educated female labor force (% of population) in Pakistan in 2002 to that in 2008?
Your answer should be compact. 1.22. What is the ratio of the Unemployed and educated female labor force (% of population) in Portugal in 2002 to that in 2008?
Offer a very short reply. 0.93. What is the ratio of the Unemployed and educated female labor force (% of population) in St. Vincent and the Grenadines in 2002 to that in 2008?
Provide a succinct answer. 1.34. What is the ratio of the Unemployed and educated female labor force (% of population) of France in 2003 to that in 2004?
Your answer should be very brief. 0.97. What is the ratio of the Unemployed and educated female labor force (% of population) in Pakistan in 2003 to that in 2004?
Your answer should be compact. 1.4. What is the ratio of the Unemployed and educated female labor force (% of population) in Portugal in 2003 to that in 2004?
Offer a terse response. 1.08. What is the ratio of the Unemployed and educated female labor force (% of population) of St. Vincent and the Grenadines in 2003 to that in 2004?
Ensure brevity in your answer.  1.08. What is the ratio of the Unemployed and educated female labor force (% of population) of France in 2003 to that in 2005?
Your response must be concise. 1.01. What is the ratio of the Unemployed and educated female labor force (% of population) in Pakistan in 2003 to that in 2005?
Your answer should be compact. 1.37. What is the ratio of the Unemployed and educated female labor force (% of population) of Portugal in 2003 to that in 2005?
Ensure brevity in your answer.  0.94. What is the ratio of the Unemployed and educated female labor force (% of population) in St. Vincent and the Grenadines in 2003 to that in 2005?
Provide a succinct answer. 1.21. What is the ratio of the Unemployed and educated female labor force (% of population) in France in 2003 to that in 2006?
Provide a succinct answer. 1. What is the ratio of the Unemployed and educated female labor force (% of population) in Pakistan in 2003 to that in 2006?
Make the answer very short. 1.51. What is the ratio of the Unemployed and educated female labor force (% of population) of St. Vincent and the Grenadines in 2003 to that in 2006?
Provide a short and direct response. 1.48. What is the ratio of the Unemployed and educated female labor force (% of population) of France in 2003 to that in 2007?
Offer a very short reply. 1. What is the ratio of the Unemployed and educated female labor force (% of population) in Pakistan in 2003 to that in 2007?
Your response must be concise. 1.24. What is the ratio of the Unemployed and educated female labor force (% of population) of Portugal in 2003 to that in 2007?
Your response must be concise. 0.99. What is the ratio of the Unemployed and educated female labor force (% of population) of St. Vincent and the Grenadines in 2003 to that in 2007?
Give a very brief answer. 1.13. What is the ratio of the Unemployed and educated female labor force (% of population) in France in 2003 to that in 2008?
Ensure brevity in your answer.  0.96. What is the ratio of the Unemployed and educated female labor force (% of population) of Pakistan in 2003 to that in 2008?
Your answer should be very brief. 1.22. What is the ratio of the Unemployed and educated female labor force (% of population) of St. Vincent and the Grenadines in 2003 to that in 2008?
Make the answer very short. 1.33. What is the ratio of the Unemployed and educated female labor force (% of population) in France in 2004 to that in 2005?
Your answer should be compact. 1.04. What is the ratio of the Unemployed and educated female labor force (% of population) of Pakistan in 2004 to that in 2005?
Give a very brief answer. 0.98. What is the ratio of the Unemployed and educated female labor force (% of population) in Portugal in 2004 to that in 2005?
Your response must be concise. 0.87. What is the ratio of the Unemployed and educated female labor force (% of population) in St. Vincent and the Grenadines in 2004 to that in 2005?
Offer a very short reply. 1.12. What is the ratio of the Unemployed and educated female labor force (% of population) in France in 2004 to that in 2006?
Offer a terse response. 1.02. What is the ratio of the Unemployed and educated female labor force (% of population) of Pakistan in 2004 to that in 2006?
Provide a succinct answer. 1.08. What is the ratio of the Unemployed and educated female labor force (% of population) in Portugal in 2004 to that in 2006?
Your response must be concise. 0.86. What is the ratio of the Unemployed and educated female labor force (% of population) in St. Vincent and the Grenadines in 2004 to that in 2006?
Provide a short and direct response. 1.37. What is the ratio of the Unemployed and educated female labor force (% of population) in France in 2004 to that in 2007?
Give a very brief answer. 1.03. What is the ratio of the Unemployed and educated female labor force (% of population) in Pakistan in 2004 to that in 2007?
Give a very brief answer. 0.89. What is the ratio of the Unemployed and educated female labor force (% of population) of Portugal in 2004 to that in 2007?
Offer a terse response. 0.92. What is the ratio of the Unemployed and educated female labor force (% of population) in St. Vincent and the Grenadines in 2004 to that in 2007?
Your answer should be very brief. 1.05. What is the ratio of the Unemployed and educated female labor force (% of population) in Pakistan in 2004 to that in 2008?
Offer a very short reply. 0.87. What is the ratio of the Unemployed and educated female labor force (% of population) in Portugal in 2004 to that in 2008?
Keep it short and to the point. 0.86. What is the ratio of the Unemployed and educated female labor force (% of population) in St. Vincent and the Grenadines in 2004 to that in 2008?
Your answer should be very brief. 1.24. What is the ratio of the Unemployed and educated female labor force (% of population) of France in 2005 to that in 2006?
Make the answer very short. 0.99. What is the ratio of the Unemployed and educated female labor force (% of population) in Pakistan in 2005 to that in 2006?
Keep it short and to the point. 1.11. What is the ratio of the Unemployed and educated female labor force (% of population) in Portugal in 2005 to that in 2006?
Provide a short and direct response. 0.99. What is the ratio of the Unemployed and educated female labor force (% of population) in St. Vincent and the Grenadines in 2005 to that in 2006?
Offer a very short reply. 1.22. What is the ratio of the Unemployed and educated female labor force (% of population) in France in 2005 to that in 2007?
Offer a terse response. 0.99. What is the ratio of the Unemployed and educated female labor force (% of population) of Pakistan in 2005 to that in 2007?
Provide a succinct answer. 0.91. What is the ratio of the Unemployed and educated female labor force (% of population) in Portugal in 2005 to that in 2007?
Offer a terse response. 1.06. What is the ratio of the Unemployed and educated female labor force (% of population) of St. Vincent and the Grenadines in 2005 to that in 2007?
Make the answer very short. 0.93. What is the ratio of the Unemployed and educated female labor force (% of population) of France in 2005 to that in 2008?
Keep it short and to the point. 0.95. What is the ratio of the Unemployed and educated female labor force (% of population) of Pakistan in 2005 to that in 2008?
Offer a very short reply. 0.89. What is the ratio of the Unemployed and educated female labor force (% of population) in St. Vincent and the Grenadines in 2005 to that in 2008?
Offer a terse response. 1.1. What is the ratio of the Unemployed and educated female labor force (% of population) of France in 2006 to that in 2007?
Ensure brevity in your answer.  1. What is the ratio of the Unemployed and educated female labor force (% of population) in Pakistan in 2006 to that in 2007?
Offer a terse response. 0.82. What is the ratio of the Unemployed and educated female labor force (% of population) in Portugal in 2006 to that in 2007?
Provide a short and direct response. 1.07. What is the ratio of the Unemployed and educated female labor force (% of population) in St. Vincent and the Grenadines in 2006 to that in 2007?
Provide a short and direct response. 0.76. What is the ratio of the Unemployed and educated female labor force (% of population) in France in 2006 to that in 2008?
Provide a short and direct response. 0.97. What is the ratio of the Unemployed and educated female labor force (% of population) of Pakistan in 2006 to that in 2008?
Provide a succinct answer. 0.8. What is the ratio of the Unemployed and educated female labor force (% of population) of St. Vincent and the Grenadines in 2006 to that in 2008?
Give a very brief answer. 0.9. What is the ratio of the Unemployed and educated female labor force (% of population) in France in 2007 to that in 2008?
Offer a terse response. 0.96. What is the ratio of the Unemployed and educated female labor force (% of population) in Pakistan in 2007 to that in 2008?
Your answer should be compact. 0.98. What is the ratio of the Unemployed and educated female labor force (% of population) of Portugal in 2007 to that in 2008?
Offer a very short reply. 0.93. What is the ratio of the Unemployed and educated female labor force (% of population) in St. Vincent and the Grenadines in 2007 to that in 2008?
Ensure brevity in your answer.  1.19. What is the difference between the highest and the second highest Unemployed and educated female labor force (% of population) in France?
Your answer should be very brief. 0.4. What is the difference between the highest and the second highest Unemployed and educated female labor force (% of population) of Pakistan?
Make the answer very short. 0. What is the difference between the highest and the second highest Unemployed and educated female labor force (% of population) of St. Vincent and the Grenadines?
Provide a short and direct response. 0.4. What is the difference between the highest and the lowest Unemployed and educated female labor force (% of population) in France?
Ensure brevity in your answer.  2. What is the difference between the highest and the lowest Unemployed and educated female labor force (% of population) in Portugal?
Ensure brevity in your answer.  2.3. 